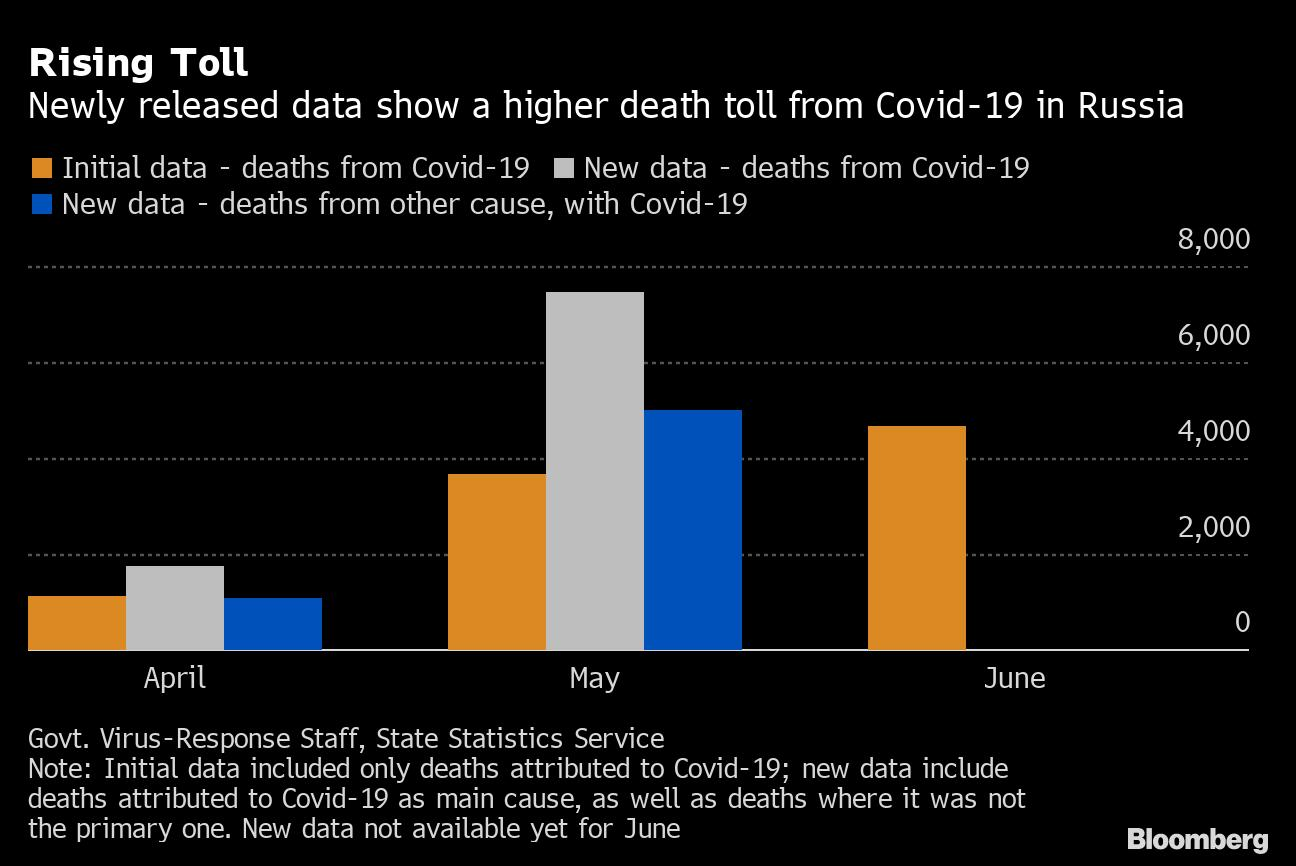List a handful of essential elements in this visual. The initial data was lower than 2000 in the month of April. The month in which the number of deaths from other causes with COVID-19 exceeded 4,000 was May. The color used to represent "new data - deaths from other causes with COVID-19" is blue. The provided data consists of three months, April, May, and June. The color yellow is used to represent initial data in certain contexts. 